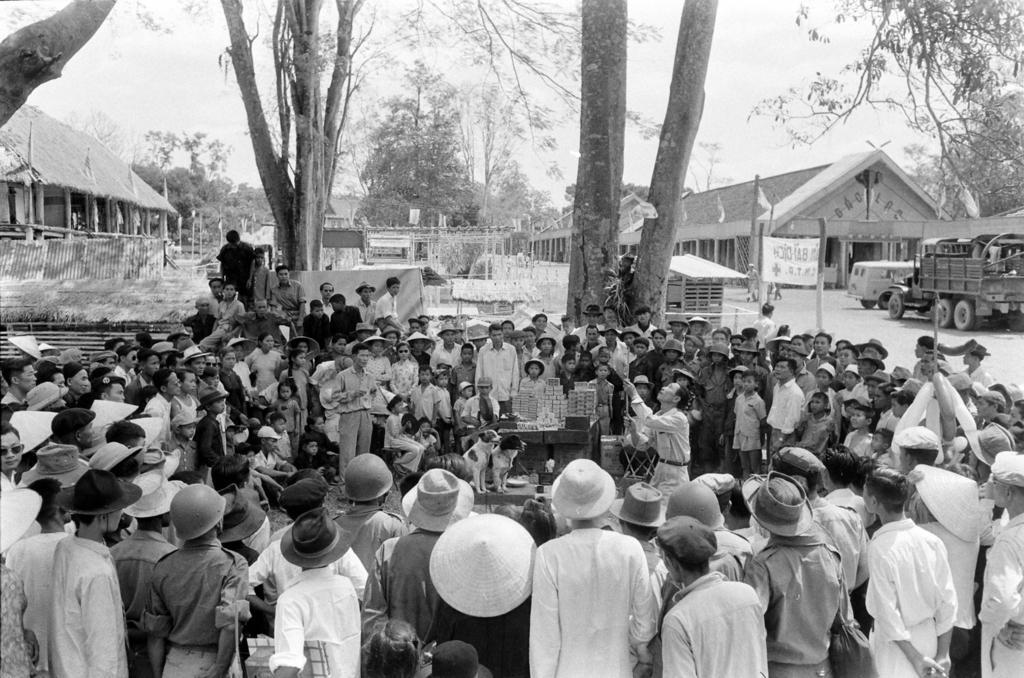How would you summarize this image in a sentence or two? This is a black and white image and here we can see people and some are wearing caps and hats and one of them is holding a stick and we can see dogs and there are some objects on the table. In the background, there are trees, sheds, poles, flags, a banner and we can see a vehicle on the road. 